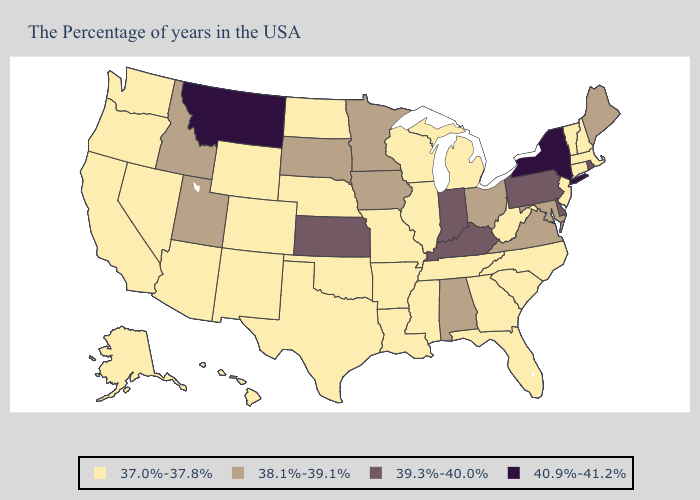Does the first symbol in the legend represent the smallest category?
Concise answer only. Yes. Does the map have missing data?
Short answer required. No. Which states have the lowest value in the Northeast?
Give a very brief answer. Massachusetts, New Hampshire, Vermont, Connecticut, New Jersey. Does Delaware have the highest value in the South?
Give a very brief answer. Yes. Among the states that border Wyoming , which have the lowest value?
Be succinct. Nebraska, Colorado. Does Virginia have the lowest value in the South?
Keep it brief. No. Name the states that have a value in the range 38.1%-39.1%?
Be succinct. Maine, Maryland, Virginia, Ohio, Alabama, Minnesota, Iowa, South Dakota, Utah, Idaho. Name the states that have a value in the range 37.0%-37.8%?
Concise answer only. Massachusetts, New Hampshire, Vermont, Connecticut, New Jersey, North Carolina, South Carolina, West Virginia, Florida, Georgia, Michigan, Tennessee, Wisconsin, Illinois, Mississippi, Louisiana, Missouri, Arkansas, Nebraska, Oklahoma, Texas, North Dakota, Wyoming, Colorado, New Mexico, Arizona, Nevada, California, Washington, Oregon, Alaska, Hawaii. Name the states that have a value in the range 38.1%-39.1%?
Short answer required. Maine, Maryland, Virginia, Ohio, Alabama, Minnesota, Iowa, South Dakota, Utah, Idaho. What is the value of Wisconsin?
Short answer required. 37.0%-37.8%. Is the legend a continuous bar?
Be succinct. No. Name the states that have a value in the range 37.0%-37.8%?
Concise answer only. Massachusetts, New Hampshire, Vermont, Connecticut, New Jersey, North Carolina, South Carolina, West Virginia, Florida, Georgia, Michigan, Tennessee, Wisconsin, Illinois, Mississippi, Louisiana, Missouri, Arkansas, Nebraska, Oklahoma, Texas, North Dakota, Wyoming, Colorado, New Mexico, Arizona, Nevada, California, Washington, Oregon, Alaska, Hawaii. What is the highest value in the Northeast ?
Concise answer only. 40.9%-41.2%. Name the states that have a value in the range 39.3%-40.0%?
Answer briefly. Rhode Island, Delaware, Pennsylvania, Kentucky, Indiana, Kansas. 